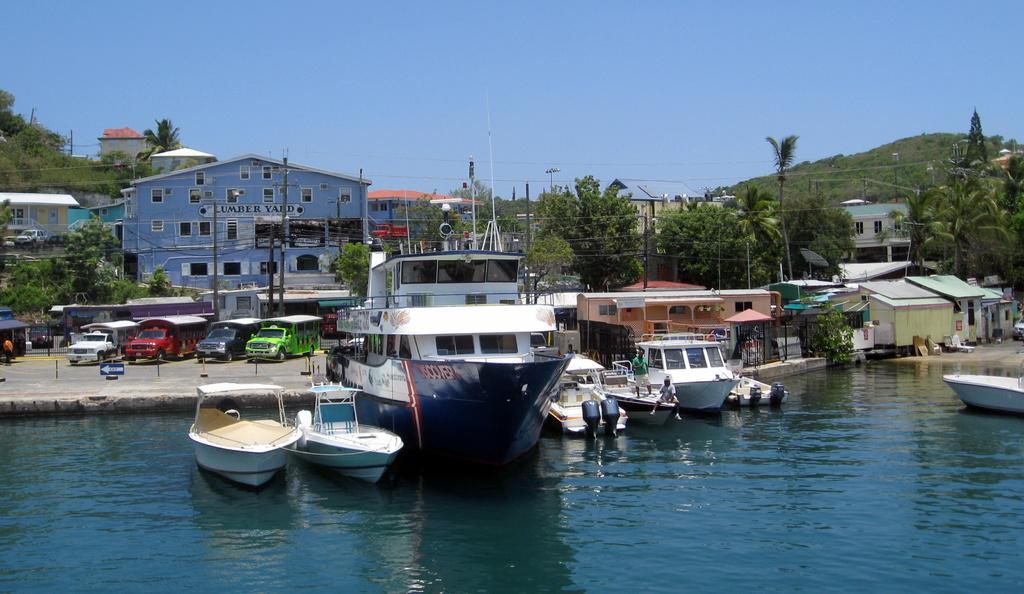Can you describe this image briefly? In this picture there are boats and ships in the center of the image on the water and there are houses, poles, vehicles, and trees in the background area of the image. 